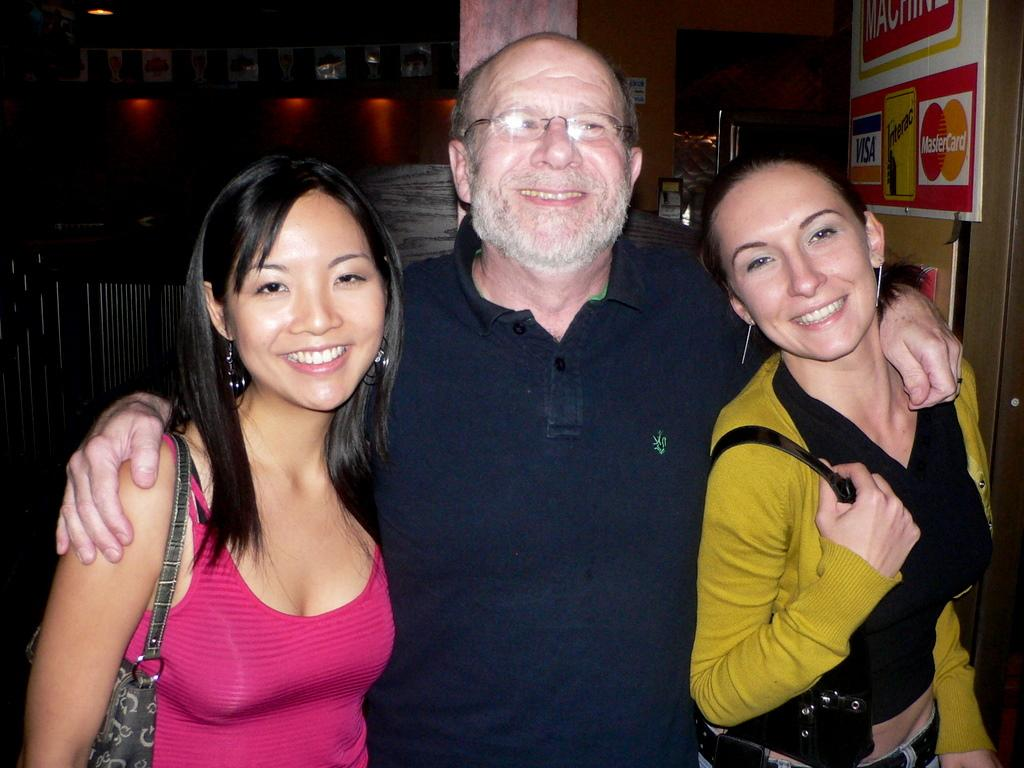How many people are in the image? There are three individuals in the image: a man and two women. What are the expressions on their faces? All three individuals are smiling in the image. Can you describe the man's appearance? The man is wearing spectacles. What type of flag is being waved by the man in the image? There is no flag present in the image. How many stomachs are visible in the image? There are no stomachs visible in the image. 